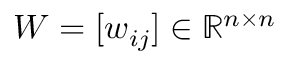Convert formula to latex. <formula><loc_0><loc_0><loc_500><loc_500>W = [ w _ { i j } ] \in \mathbb { R } ^ { n \times n }</formula> 